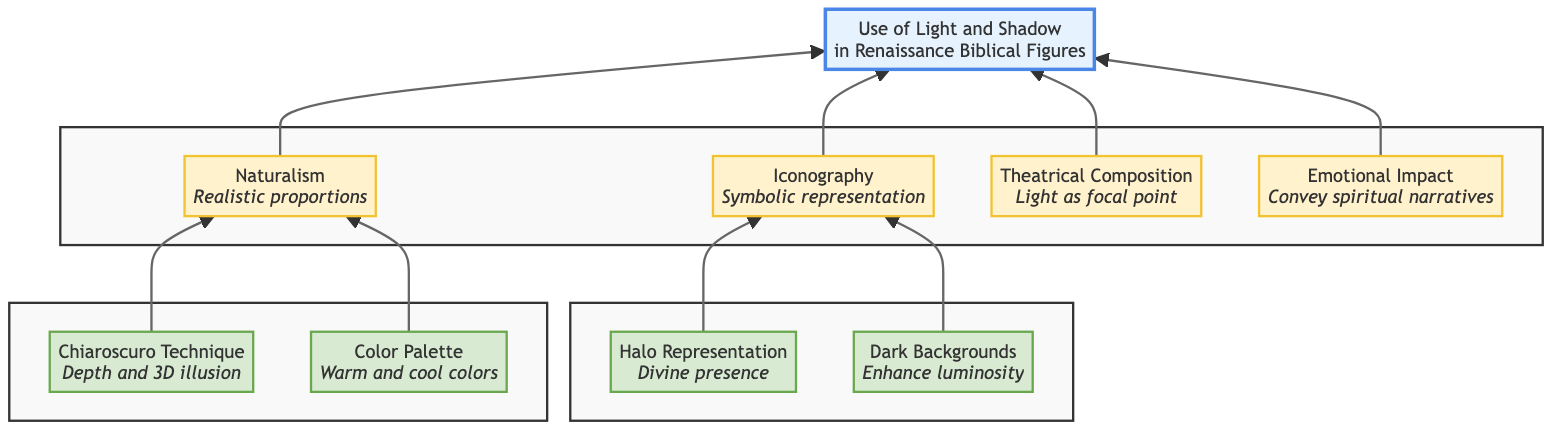What is the primary focus of the diagram? The diagram primarily focuses on the "Use of Light and Shadow in Renaissance Biblical Figures," as indicated by the root node at the top.
Answer: Use of Light and Shadow in Renaissance Biblical Figures How many main categories are listed in the diagram? There are four main categories listed branching from the root node: Naturalism, Iconography, Theatrical Composition, and Emotional Impact.
Answer: 4 Which technique is associated with Naturalism for creating depth? The Chiaroscuro Technique is directly connected to Naturalism, emphasizing the use of light and shadow for depth.
Answer: Chiaroscuro Technique What iconographic element represents divine presence? The Halo Representation is the iconographic element that denotes divine presence surrounding figures, as shown in the children nodes under Iconography.
Answer: Halo Representation Which category does the Dark Backgrounds belong to? Dark Backgrounds is a child node under the Iconography category, indicating its relationship to symbolic representation.
Answer: Iconography How does the diagram classify the emotional narrative conveyed through light? The diagram classifies it under the Emotional Impact node, which highlights the use of light and shadow for conveying spiritual narratives.
Answer: Emotional Impact Which two techniques are listed under Naturalism? The two techniques listed under Naturalism are Chiaroscuro Technique and Color Palette.
Answer: Chiaroscuro Technique and Color Palette What role do shadows play in highlighting important figures? Shadows are used in the context of Dark Backgrounds to enhance the luminosity of important figures in the Iconography category.
Answer: Enhance luminosity Does the diagram include any relationship between Naturalism and Iconography? Yes, both Naturalism and Iconography contain techniques and elements that contribute to the overall use of light and shadow in conveying messages in Renaissance paintings.
Answer: Yes 